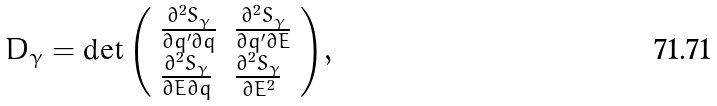<formula> <loc_0><loc_0><loc_500><loc_500>D _ { \gamma } = \det { \left ( \begin{array} { l l } \frac { \partial ^ { 2 } S _ { \gamma } } { \partial { q ^ { \prime } } \partial { q } } & \frac { \partial ^ { 2 } S _ { \gamma } } { \partial { q ^ { \prime } } \partial E } \\ \frac { \partial ^ { 2 } S _ { \gamma } } { \partial E \partial { q } } & \frac { \partial ^ { 2 } S _ { \gamma } } { \partial E ^ { 2 } } \end{array} \right ) } ,</formula> 